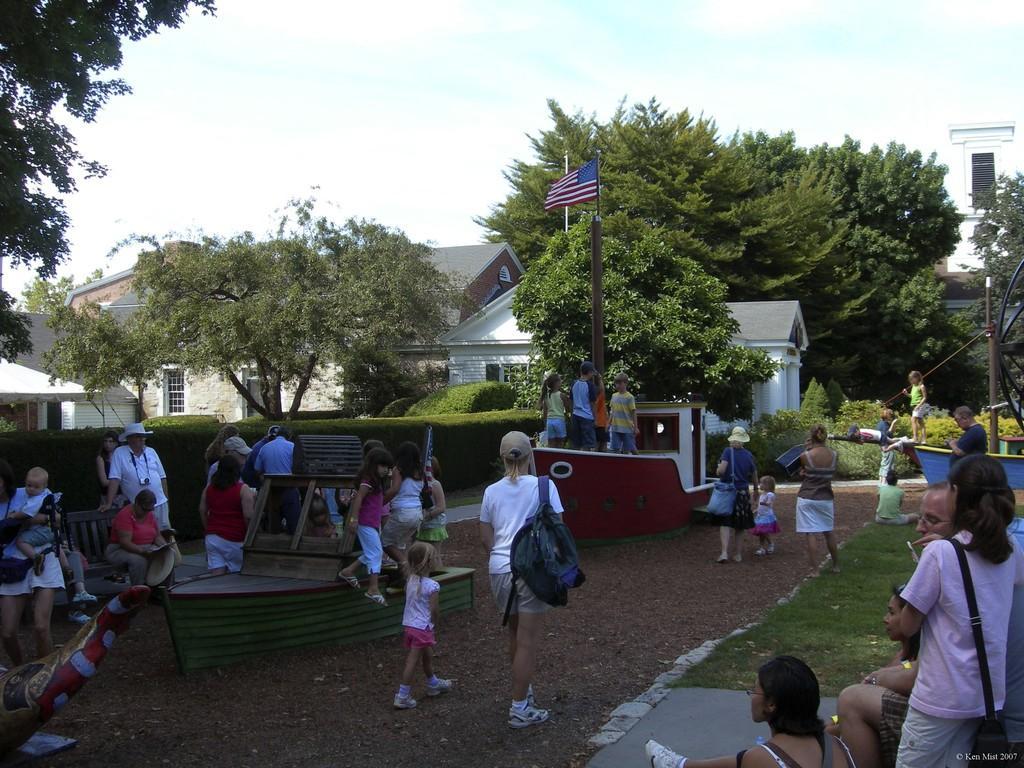Could you give a brief overview of what you see in this image? In the center of the image there are people. In the background of the image there are houses,trees. There is a flag. At the top of the image there is sky. 